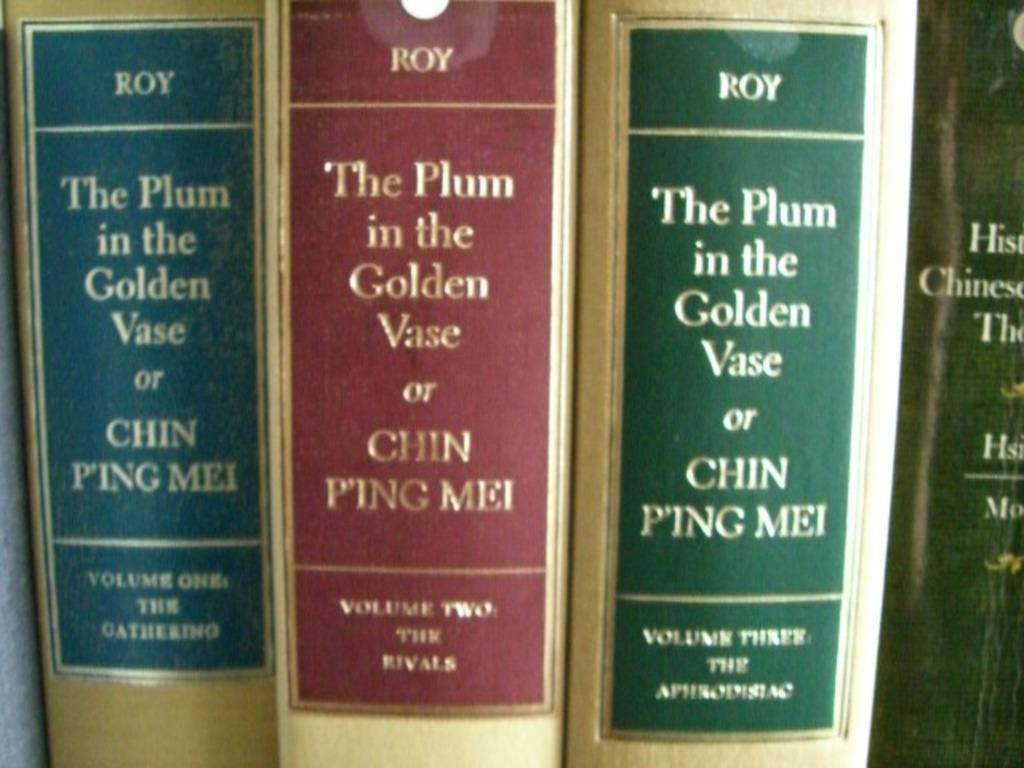<image>
Write a terse but informative summary of the picture. Volumes 1, 2 and 3 of The Plum in the Golden Vase sit in a row 